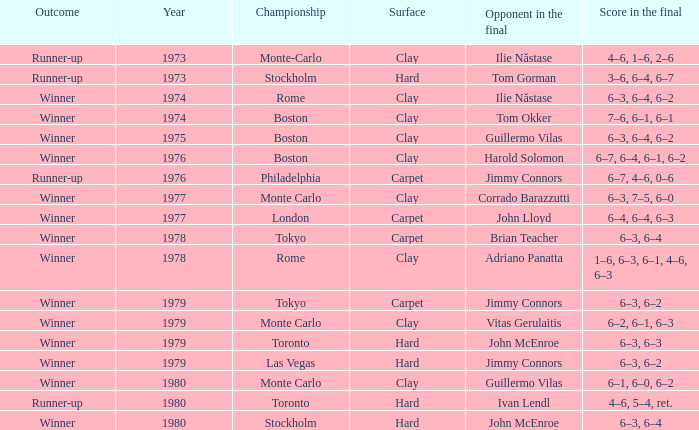State the time span in years for 6-3, 6-2 hard court. 1.0. 